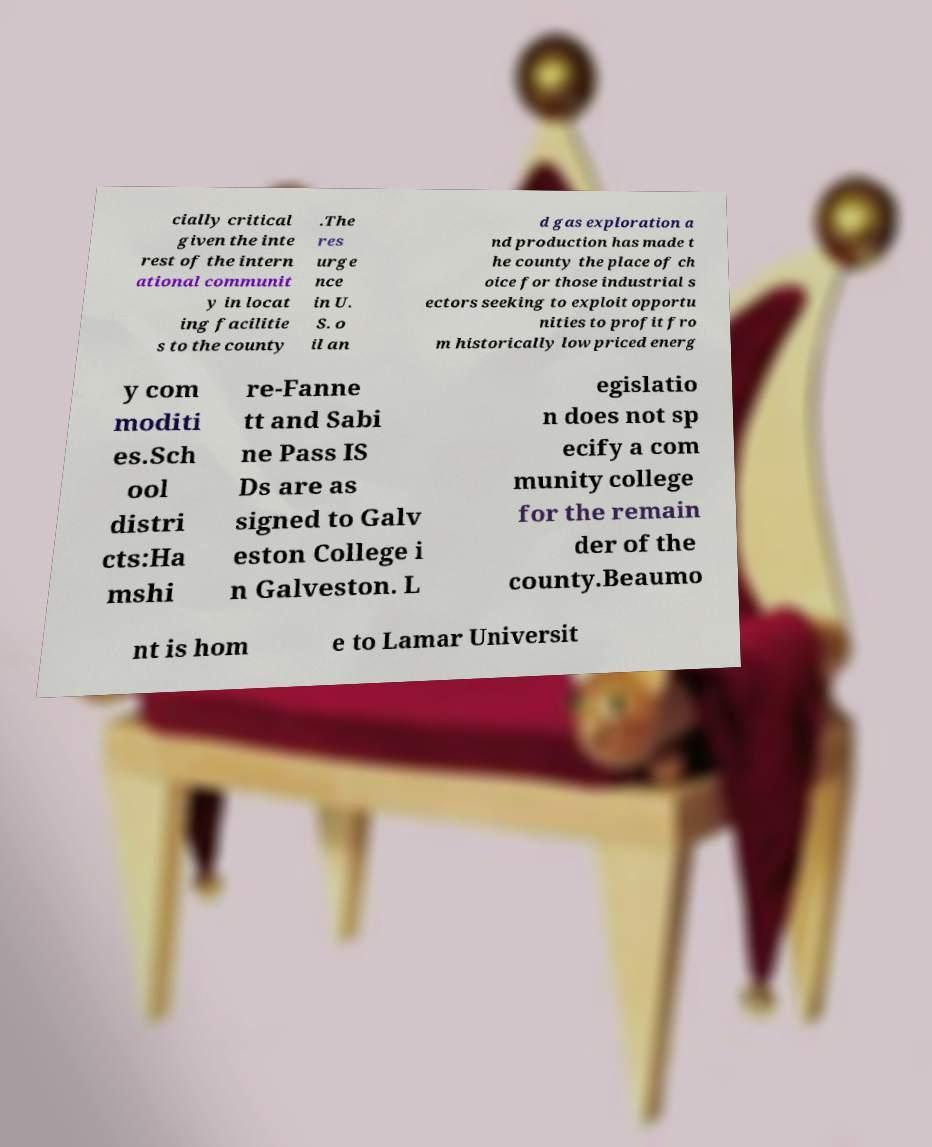Please read and relay the text visible in this image. What does it say? cially critical given the inte rest of the intern ational communit y in locat ing facilitie s to the county .The res urge nce in U. S. o il an d gas exploration a nd production has made t he county the place of ch oice for those industrial s ectors seeking to exploit opportu nities to profit fro m historically low priced energ y com moditi es.Sch ool distri cts:Ha mshi re-Fanne tt and Sabi ne Pass IS Ds are as signed to Galv eston College i n Galveston. L egislatio n does not sp ecify a com munity college for the remain der of the county.Beaumo nt is hom e to Lamar Universit 